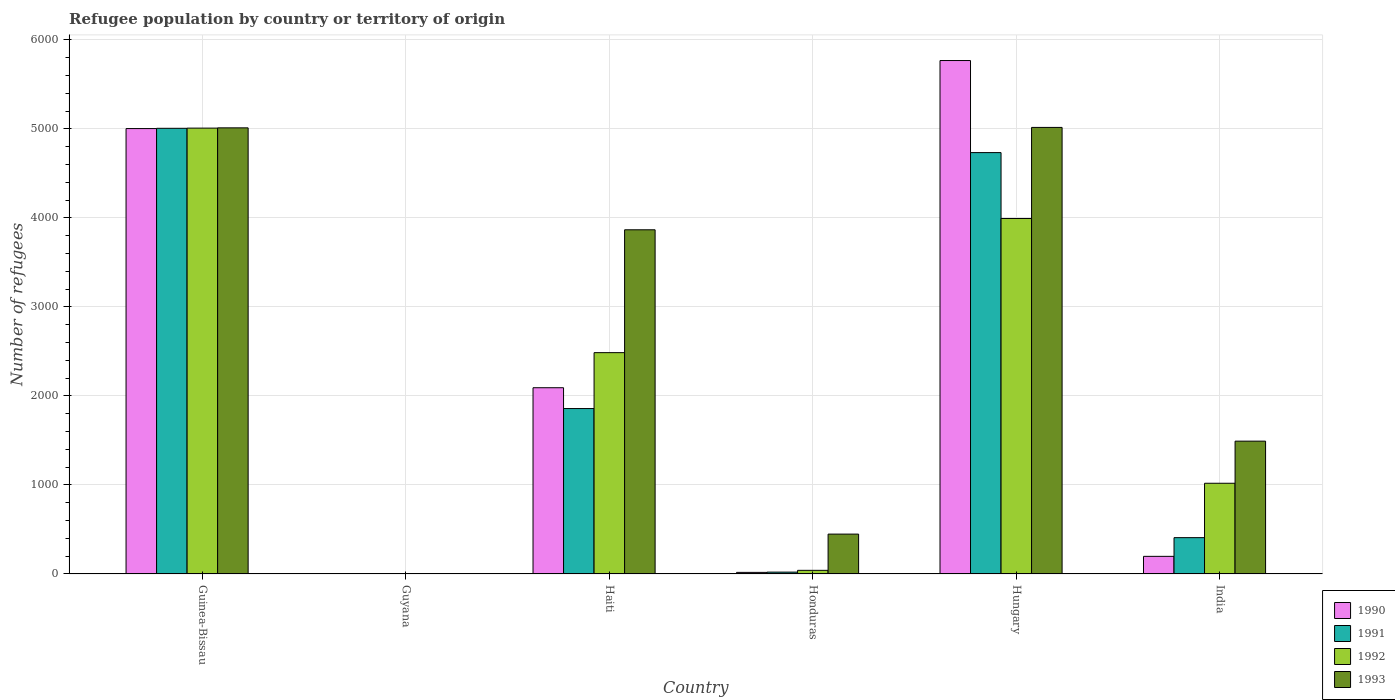How many different coloured bars are there?
Your answer should be very brief. 4. What is the label of the 4th group of bars from the left?
Give a very brief answer. Honduras. What is the number of refugees in 1991 in India?
Make the answer very short. 408. Across all countries, what is the maximum number of refugees in 1993?
Keep it short and to the point. 5016. In which country was the number of refugees in 1990 maximum?
Offer a terse response. Hungary. In which country was the number of refugees in 1993 minimum?
Offer a terse response. Guyana. What is the total number of refugees in 1990 in the graph?
Keep it short and to the point. 1.31e+04. What is the difference between the number of refugees in 1993 in Guyana and that in Hungary?
Keep it short and to the point. -5012. What is the difference between the number of refugees in 1990 in Honduras and the number of refugees in 1991 in Hungary?
Offer a very short reply. -4715. What is the average number of refugees in 1990 per country?
Offer a terse response. 2180. What is the difference between the number of refugees of/in 1990 and number of refugees of/in 1993 in Haiti?
Make the answer very short. -1774. What is the ratio of the number of refugees in 1993 in Guyana to that in India?
Offer a terse response. 0. What is the difference between the highest and the second highest number of refugees in 1991?
Provide a short and direct response. -2875. What is the difference between the highest and the lowest number of refugees in 1991?
Make the answer very short. 5005. In how many countries, is the number of refugees in 1991 greater than the average number of refugees in 1991 taken over all countries?
Keep it short and to the point. 2. Is the sum of the number of refugees in 1990 in Haiti and Hungary greater than the maximum number of refugees in 1992 across all countries?
Keep it short and to the point. Yes. What does the 3rd bar from the left in Honduras represents?
Keep it short and to the point. 1992. What does the 1st bar from the right in Honduras represents?
Offer a terse response. 1993. What is the difference between two consecutive major ticks on the Y-axis?
Your response must be concise. 1000. Are the values on the major ticks of Y-axis written in scientific E-notation?
Offer a terse response. No. Does the graph contain grids?
Ensure brevity in your answer.  Yes. How many legend labels are there?
Provide a succinct answer. 4. What is the title of the graph?
Offer a terse response. Refugee population by country or territory of origin. Does "1975" appear as one of the legend labels in the graph?
Your answer should be compact. No. What is the label or title of the X-axis?
Provide a succinct answer. Country. What is the label or title of the Y-axis?
Your answer should be compact. Number of refugees. What is the Number of refugees in 1990 in Guinea-Bissau?
Ensure brevity in your answer.  5003. What is the Number of refugees of 1991 in Guinea-Bissau?
Your answer should be very brief. 5006. What is the Number of refugees in 1992 in Guinea-Bissau?
Provide a short and direct response. 5008. What is the Number of refugees of 1993 in Guinea-Bissau?
Ensure brevity in your answer.  5011. What is the Number of refugees in 1991 in Guyana?
Your answer should be compact. 1. What is the Number of refugees in 1992 in Guyana?
Provide a succinct answer. 2. What is the Number of refugees in 1990 in Haiti?
Offer a very short reply. 2092. What is the Number of refugees in 1991 in Haiti?
Ensure brevity in your answer.  1858. What is the Number of refugees in 1992 in Haiti?
Keep it short and to the point. 2486. What is the Number of refugees of 1993 in Haiti?
Provide a short and direct response. 3866. What is the Number of refugees in 1993 in Honduras?
Give a very brief answer. 448. What is the Number of refugees in 1990 in Hungary?
Give a very brief answer. 5767. What is the Number of refugees in 1991 in Hungary?
Offer a very short reply. 4733. What is the Number of refugees in 1992 in Hungary?
Ensure brevity in your answer.  3993. What is the Number of refugees of 1993 in Hungary?
Your response must be concise. 5016. What is the Number of refugees in 1990 in India?
Give a very brief answer. 198. What is the Number of refugees in 1991 in India?
Provide a short and direct response. 408. What is the Number of refugees in 1992 in India?
Your answer should be compact. 1019. What is the Number of refugees in 1993 in India?
Offer a very short reply. 1492. Across all countries, what is the maximum Number of refugees in 1990?
Your answer should be very brief. 5767. Across all countries, what is the maximum Number of refugees of 1991?
Provide a short and direct response. 5006. Across all countries, what is the maximum Number of refugees of 1992?
Give a very brief answer. 5008. Across all countries, what is the maximum Number of refugees in 1993?
Keep it short and to the point. 5016. Across all countries, what is the minimum Number of refugees of 1991?
Your response must be concise. 1. What is the total Number of refugees of 1990 in the graph?
Your answer should be very brief. 1.31e+04. What is the total Number of refugees of 1991 in the graph?
Provide a short and direct response. 1.20e+04. What is the total Number of refugees of 1992 in the graph?
Offer a terse response. 1.25e+04. What is the total Number of refugees of 1993 in the graph?
Offer a terse response. 1.58e+04. What is the difference between the Number of refugees of 1990 in Guinea-Bissau and that in Guyana?
Provide a short and direct response. 5001. What is the difference between the Number of refugees of 1991 in Guinea-Bissau and that in Guyana?
Offer a very short reply. 5005. What is the difference between the Number of refugees in 1992 in Guinea-Bissau and that in Guyana?
Your answer should be compact. 5006. What is the difference between the Number of refugees in 1993 in Guinea-Bissau and that in Guyana?
Your answer should be very brief. 5007. What is the difference between the Number of refugees in 1990 in Guinea-Bissau and that in Haiti?
Make the answer very short. 2911. What is the difference between the Number of refugees in 1991 in Guinea-Bissau and that in Haiti?
Your response must be concise. 3148. What is the difference between the Number of refugees of 1992 in Guinea-Bissau and that in Haiti?
Provide a succinct answer. 2522. What is the difference between the Number of refugees of 1993 in Guinea-Bissau and that in Haiti?
Provide a succinct answer. 1145. What is the difference between the Number of refugees in 1990 in Guinea-Bissau and that in Honduras?
Your answer should be very brief. 4985. What is the difference between the Number of refugees in 1991 in Guinea-Bissau and that in Honduras?
Your answer should be compact. 4985. What is the difference between the Number of refugees of 1992 in Guinea-Bissau and that in Honduras?
Keep it short and to the point. 4967. What is the difference between the Number of refugees in 1993 in Guinea-Bissau and that in Honduras?
Offer a very short reply. 4563. What is the difference between the Number of refugees of 1990 in Guinea-Bissau and that in Hungary?
Your response must be concise. -764. What is the difference between the Number of refugees of 1991 in Guinea-Bissau and that in Hungary?
Offer a terse response. 273. What is the difference between the Number of refugees of 1992 in Guinea-Bissau and that in Hungary?
Ensure brevity in your answer.  1015. What is the difference between the Number of refugees in 1990 in Guinea-Bissau and that in India?
Give a very brief answer. 4805. What is the difference between the Number of refugees in 1991 in Guinea-Bissau and that in India?
Your answer should be very brief. 4598. What is the difference between the Number of refugees in 1992 in Guinea-Bissau and that in India?
Make the answer very short. 3989. What is the difference between the Number of refugees of 1993 in Guinea-Bissau and that in India?
Offer a very short reply. 3519. What is the difference between the Number of refugees in 1990 in Guyana and that in Haiti?
Provide a short and direct response. -2090. What is the difference between the Number of refugees of 1991 in Guyana and that in Haiti?
Ensure brevity in your answer.  -1857. What is the difference between the Number of refugees of 1992 in Guyana and that in Haiti?
Make the answer very short. -2484. What is the difference between the Number of refugees in 1993 in Guyana and that in Haiti?
Provide a short and direct response. -3862. What is the difference between the Number of refugees of 1990 in Guyana and that in Honduras?
Make the answer very short. -16. What is the difference between the Number of refugees of 1991 in Guyana and that in Honduras?
Give a very brief answer. -20. What is the difference between the Number of refugees of 1992 in Guyana and that in Honduras?
Your response must be concise. -39. What is the difference between the Number of refugees of 1993 in Guyana and that in Honduras?
Your answer should be compact. -444. What is the difference between the Number of refugees of 1990 in Guyana and that in Hungary?
Ensure brevity in your answer.  -5765. What is the difference between the Number of refugees in 1991 in Guyana and that in Hungary?
Offer a terse response. -4732. What is the difference between the Number of refugees of 1992 in Guyana and that in Hungary?
Your response must be concise. -3991. What is the difference between the Number of refugees in 1993 in Guyana and that in Hungary?
Your answer should be very brief. -5012. What is the difference between the Number of refugees of 1990 in Guyana and that in India?
Make the answer very short. -196. What is the difference between the Number of refugees of 1991 in Guyana and that in India?
Provide a succinct answer. -407. What is the difference between the Number of refugees of 1992 in Guyana and that in India?
Provide a short and direct response. -1017. What is the difference between the Number of refugees of 1993 in Guyana and that in India?
Your response must be concise. -1488. What is the difference between the Number of refugees in 1990 in Haiti and that in Honduras?
Your response must be concise. 2074. What is the difference between the Number of refugees of 1991 in Haiti and that in Honduras?
Give a very brief answer. 1837. What is the difference between the Number of refugees in 1992 in Haiti and that in Honduras?
Your response must be concise. 2445. What is the difference between the Number of refugees of 1993 in Haiti and that in Honduras?
Make the answer very short. 3418. What is the difference between the Number of refugees of 1990 in Haiti and that in Hungary?
Give a very brief answer. -3675. What is the difference between the Number of refugees in 1991 in Haiti and that in Hungary?
Offer a very short reply. -2875. What is the difference between the Number of refugees in 1992 in Haiti and that in Hungary?
Ensure brevity in your answer.  -1507. What is the difference between the Number of refugees in 1993 in Haiti and that in Hungary?
Offer a very short reply. -1150. What is the difference between the Number of refugees of 1990 in Haiti and that in India?
Your answer should be very brief. 1894. What is the difference between the Number of refugees of 1991 in Haiti and that in India?
Give a very brief answer. 1450. What is the difference between the Number of refugees in 1992 in Haiti and that in India?
Your answer should be compact. 1467. What is the difference between the Number of refugees in 1993 in Haiti and that in India?
Your answer should be very brief. 2374. What is the difference between the Number of refugees of 1990 in Honduras and that in Hungary?
Offer a terse response. -5749. What is the difference between the Number of refugees of 1991 in Honduras and that in Hungary?
Offer a terse response. -4712. What is the difference between the Number of refugees of 1992 in Honduras and that in Hungary?
Give a very brief answer. -3952. What is the difference between the Number of refugees in 1993 in Honduras and that in Hungary?
Provide a succinct answer. -4568. What is the difference between the Number of refugees in 1990 in Honduras and that in India?
Provide a short and direct response. -180. What is the difference between the Number of refugees of 1991 in Honduras and that in India?
Ensure brevity in your answer.  -387. What is the difference between the Number of refugees in 1992 in Honduras and that in India?
Your answer should be compact. -978. What is the difference between the Number of refugees in 1993 in Honduras and that in India?
Your response must be concise. -1044. What is the difference between the Number of refugees of 1990 in Hungary and that in India?
Ensure brevity in your answer.  5569. What is the difference between the Number of refugees of 1991 in Hungary and that in India?
Give a very brief answer. 4325. What is the difference between the Number of refugees of 1992 in Hungary and that in India?
Give a very brief answer. 2974. What is the difference between the Number of refugees of 1993 in Hungary and that in India?
Ensure brevity in your answer.  3524. What is the difference between the Number of refugees of 1990 in Guinea-Bissau and the Number of refugees of 1991 in Guyana?
Offer a very short reply. 5002. What is the difference between the Number of refugees in 1990 in Guinea-Bissau and the Number of refugees in 1992 in Guyana?
Give a very brief answer. 5001. What is the difference between the Number of refugees in 1990 in Guinea-Bissau and the Number of refugees in 1993 in Guyana?
Your response must be concise. 4999. What is the difference between the Number of refugees of 1991 in Guinea-Bissau and the Number of refugees of 1992 in Guyana?
Provide a short and direct response. 5004. What is the difference between the Number of refugees of 1991 in Guinea-Bissau and the Number of refugees of 1993 in Guyana?
Offer a very short reply. 5002. What is the difference between the Number of refugees of 1992 in Guinea-Bissau and the Number of refugees of 1993 in Guyana?
Your answer should be very brief. 5004. What is the difference between the Number of refugees in 1990 in Guinea-Bissau and the Number of refugees in 1991 in Haiti?
Offer a very short reply. 3145. What is the difference between the Number of refugees of 1990 in Guinea-Bissau and the Number of refugees of 1992 in Haiti?
Keep it short and to the point. 2517. What is the difference between the Number of refugees in 1990 in Guinea-Bissau and the Number of refugees in 1993 in Haiti?
Offer a very short reply. 1137. What is the difference between the Number of refugees of 1991 in Guinea-Bissau and the Number of refugees of 1992 in Haiti?
Your answer should be very brief. 2520. What is the difference between the Number of refugees in 1991 in Guinea-Bissau and the Number of refugees in 1993 in Haiti?
Keep it short and to the point. 1140. What is the difference between the Number of refugees of 1992 in Guinea-Bissau and the Number of refugees of 1993 in Haiti?
Give a very brief answer. 1142. What is the difference between the Number of refugees in 1990 in Guinea-Bissau and the Number of refugees in 1991 in Honduras?
Keep it short and to the point. 4982. What is the difference between the Number of refugees of 1990 in Guinea-Bissau and the Number of refugees of 1992 in Honduras?
Your response must be concise. 4962. What is the difference between the Number of refugees of 1990 in Guinea-Bissau and the Number of refugees of 1993 in Honduras?
Your response must be concise. 4555. What is the difference between the Number of refugees in 1991 in Guinea-Bissau and the Number of refugees in 1992 in Honduras?
Your response must be concise. 4965. What is the difference between the Number of refugees of 1991 in Guinea-Bissau and the Number of refugees of 1993 in Honduras?
Give a very brief answer. 4558. What is the difference between the Number of refugees in 1992 in Guinea-Bissau and the Number of refugees in 1993 in Honduras?
Your answer should be very brief. 4560. What is the difference between the Number of refugees in 1990 in Guinea-Bissau and the Number of refugees in 1991 in Hungary?
Your answer should be compact. 270. What is the difference between the Number of refugees of 1990 in Guinea-Bissau and the Number of refugees of 1992 in Hungary?
Give a very brief answer. 1010. What is the difference between the Number of refugees in 1990 in Guinea-Bissau and the Number of refugees in 1993 in Hungary?
Your answer should be very brief. -13. What is the difference between the Number of refugees in 1991 in Guinea-Bissau and the Number of refugees in 1992 in Hungary?
Give a very brief answer. 1013. What is the difference between the Number of refugees of 1990 in Guinea-Bissau and the Number of refugees of 1991 in India?
Ensure brevity in your answer.  4595. What is the difference between the Number of refugees of 1990 in Guinea-Bissau and the Number of refugees of 1992 in India?
Your answer should be compact. 3984. What is the difference between the Number of refugees of 1990 in Guinea-Bissau and the Number of refugees of 1993 in India?
Make the answer very short. 3511. What is the difference between the Number of refugees in 1991 in Guinea-Bissau and the Number of refugees in 1992 in India?
Make the answer very short. 3987. What is the difference between the Number of refugees of 1991 in Guinea-Bissau and the Number of refugees of 1993 in India?
Your answer should be very brief. 3514. What is the difference between the Number of refugees in 1992 in Guinea-Bissau and the Number of refugees in 1993 in India?
Provide a short and direct response. 3516. What is the difference between the Number of refugees in 1990 in Guyana and the Number of refugees in 1991 in Haiti?
Offer a terse response. -1856. What is the difference between the Number of refugees of 1990 in Guyana and the Number of refugees of 1992 in Haiti?
Ensure brevity in your answer.  -2484. What is the difference between the Number of refugees of 1990 in Guyana and the Number of refugees of 1993 in Haiti?
Provide a short and direct response. -3864. What is the difference between the Number of refugees in 1991 in Guyana and the Number of refugees in 1992 in Haiti?
Keep it short and to the point. -2485. What is the difference between the Number of refugees of 1991 in Guyana and the Number of refugees of 1993 in Haiti?
Offer a terse response. -3865. What is the difference between the Number of refugees of 1992 in Guyana and the Number of refugees of 1993 in Haiti?
Your answer should be compact. -3864. What is the difference between the Number of refugees in 1990 in Guyana and the Number of refugees in 1992 in Honduras?
Offer a terse response. -39. What is the difference between the Number of refugees in 1990 in Guyana and the Number of refugees in 1993 in Honduras?
Give a very brief answer. -446. What is the difference between the Number of refugees of 1991 in Guyana and the Number of refugees of 1992 in Honduras?
Offer a terse response. -40. What is the difference between the Number of refugees in 1991 in Guyana and the Number of refugees in 1993 in Honduras?
Provide a short and direct response. -447. What is the difference between the Number of refugees in 1992 in Guyana and the Number of refugees in 1993 in Honduras?
Your response must be concise. -446. What is the difference between the Number of refugees in 1990 in Guyana and the Number of refugees in 1991 in Hungary?
Ensure brevity in your answer.  -4731. What is the difference between the Number of refugees of 1990 in Guyana and the Number of refugees of 1992 in Hungary?
Provide a succinct answer. -3991. What is the difference between the Number of refugees in 1990 in Guyana and the Number of refugees in 1993 in Hungary?
Keep it short and to the point. -5014. What is the difference between the Number of refugees in 1991 in Guyana and the Number of refugees in 1992 in Hungary?
Provide a succinct answer. -3992. What is the difference between the Number of refugees of 1991 in Guyana and the Number of refugees of 1993 in Hungary?
Offer a very short reply. -5015. What is the difference between the Number of refugees in 1992 in Guyana and the Number of refugees in 1993 in Hungary?
Your response must be concise. -5014. What is the difference between the Number of refugees in 1990 in Guyana and the Number of refugees in 1991 in India?
Your response must be concise. -406. What is the difference between the Number of refugees of 1990 in Guyana and the Number of refugees of 1992 in India?
Your answer should be very brief. -1017. What is the difference between the Number of refugees in 1990 in Guyana and the Number of refugees in 1993 in India?
Your response must be concise. -1490. What is the difference between the Number of refugees of 1991 in Guyana and the Number of refugees of 1992 in India?
Make the answer very short. -1018. What is the difference between the Number of refugees of 1991 in Guyana and the Number of refugees of 1993 in India?
Make the answer very short. -1491. What is the difference between the Number of refugees of 1992 in Guyana and the Number of refugees of 1993 in India?
Offer a very short reply. -1490. What is the difference between the Number of refugees in 1990 in Haiti and the Number of refugees in 1991 in Honduras?
Offer a terse response. 2071. What is the difference between the Number of refugees in 1990 in Haiti and the Number of refugees in 1992 in Honduras?
Give a very brief answer. 2051. What is the difference between the Number of refugees of 1990 in Haiti and the Number of refugees of 1993 in Honduras?
Provide a succinct answer. 1644. What is the difference between the Number of refugees in 1991 in Haiti and the Number of refugees in 1992 in Honduras?
Offer a terse response. 1817. What is the difference between the Number of refugees of 1991 in Haiti and the Number of refugees of 1993 in Honduras?
Your response must be concise. 1410. What is the difference between the Number of refugees in 1992 in Haiti and the Number of refugees in 1993 in Honduras?
Provide a short and direct response. 2038. What is the difference between the Number of refugees in 1990 in Haiti and the Number of refugees in 1991 in Hungary?
Your response must be concise. -2641. What is the difference between the Number of refugees of 1990 in Haiti and the Number of refugees of 1992 in Hungary?
Provide a short and direct response. -1901. What is the difference between the Number of refugees in 1990 in Haiti and the Number of refugees in 1993 in Hungary?
Offer a terse response. -2924. What is the difference between the Number of refugees of 1991 in Haiti and the Number of refugees of 1992 in Hungary?
Your answer should be compact. -2135. What is the difference between the Number of refugees of 1991 in Haiti and the Number of refugees of 1993 in Hungary?
Provide a short and direct response. -3158. What is the difference between the Number of refugees in 1992 in Haiti and the Number of refugees in 1993 in Hungary?
Provide a succinct answer. -2530. What is the difference between the Number of refugees of 1990 in Haiti and the Number of refugees of 1991 in India?
Provide a succinct answer. 1684. What is the difference between the Number of refugees of 1990 in Haiti and the Number of refugees of 1992 in India?
Provide a succinct answer. 1073. What is the difference between the Number of refugees of 1990 in Haiti and the Number of refugees of 1993 in India?
Your answer should be very brief. 600. What is the difference between the Number of refugees of 1991 in Haiti and the Number of refugees of 1992 in India?
Ensure brevity in your answer.  839. What is the difference between the Number of refugees of 1991 in Haiti and the Number of refugees of 1993 in India?
Your answer should be very brief. 366. What is the difference between the Number of refugees in 1992 in Haiti and the Number of refugees in 1993 in India?
Provide a succinct answer. 994. What is the difference between the Number of refugees of 1990 in Honduras and the Number of refugees of 1991 in Hungary?
Your answer should be very brief. -4715. What is the difference between the Number of refugees in 1990 in Honduras and the Number of refugees in 1992 in Hungary?
Provide a succinct answer. -3975. What is the difference between the Number of refugees of 1990 in Honduras and the Number of refugees of 1993 in Hungary?
Your response must be concise. -4998. What is the difference between the Number of refugees of 1991 in Honduras and the Number of refugees of 1992 in Hungary?
Your answer should be compact. -3972. What is the difference between the Number of refugees of 1991 in Honduras and the Number of refugees of 1993 in Hungary?
Make the answer very short. -4995. What is the difference between the Number of refugees in 1992 in Honduras and the Number of refugees in 1993 in Hungary?
Your response must be concise. -4975. What is the difference between the Number of refugees in 1990 in Honduras and the Number of refugees in 1991 in India?
Offer a terse response. -390. What is the difference between the Number of refugees of 1990 in Honduras and the Number of refugees of 1992 in India?
Provide a short and direct response. -1001. What is the difference between the Number of refugees of 1990 in Honduras and the Number of refugees of 1993 in India?
Your answer should be compact. -1474. What is the difference between the Number of refugees of 1991 in Honduras and the Number of refugees of 1992 in India?
Keep it short and to the point. -998. What is the difference between the Number of refugees of 1991 in Honduras and the Number of refugees of 1993 in India?
Provide a succinct answer. -1471. What is the difference between the Number of refugees in 1992 in Honduras and the Number of refugees in 1993 in India?
Give a very brief answer. -1451. What is the difference between the Number of refugees of 1990 in Hungary and the Number of refugees of 1991 in India?
Give a very brief answer. 5359. What is the difference between the Number of refugees in 1990 in Hungary and the Number of refugees in 1992 in India?
Ensure brevity in your answer.  4748. What is the difference between the Number of refugees in 1990 in Hungary and the Number of refugees in 1993 in India?
Offer a very short reply. 4275. What is the difference between the Number of refugees in 1991 in Hungary and the Number of refugees in 1992 in India?
Give a very brief answer. 3714. What is the difference between the Number of refugees in 1991 in Hungary and the Number of refugees in 1993 in India?
Ensure brevity in your answer.  3241. What is the difference between the Number of refugees in 1992 in Hungary and the Number of refugees in 1993 in India?
Offer a terse response. 2501. What is the average Number of refugees of 1990 per country?
Your answer should be compact. 2180. What is the average Number of refugees in 1991 per country?
Offer a very short reply. 2004.5. What is the average Number of refugees in 1992 per country?
Offer a terse response. 2091.5. What is the average Number of refugees of 1993 per country?
Provide a succinct answer. 2639.5. What is the difference between the Number of refugees in 1990 and Number of refugees in 1991 in Guinea-Bissau?
Offer a very short reply. -3. What is the difference between the Number of refugees of 1992 and Number of refugees of 1993 in Guinea-Bissau?
Provide a succinct answer. -3. What is the difference between the Number of refugees of 1990 and Number of refugees of 1991 in Guyana?
Provide a short and direct response. 1. What is the difference between the Number of refugees of 1991 and Number of refugees of 1992 in Guyana?
Ensure brevity in your answer.  -1. What is the difference between the Number of refugees of 1991 and Number of refugees of 1993 in Guyana?
Your response must be concise. -3. What is the difference between the Number of refugees of 1992 and Number of refugees of 1993 in Guyana?
Provide a short and direct response. -2. What is the difference between the Number of refugees of 1990 and Number of refugees of 1991 in Haiti?
Provide a succinct answer. 234. What is the difference between the Number of refugees of 1990 and Number of refugees of 1992 in Haiti?
Your answer should be compact. -394. What is the difference between the Number of refugees of 1990 and Number of refugees of 1993 in Haiti?
Provide a succinct answer. -1774. What is the difference between the Number of refugees of 1991 and Number of refugees of 1992 in Haiti?
Keep it short and to the point. -628. What is the difference between the Number of refugees of 1991 and Number of refugees of 1993 in Haiti?
Your answer should be compact. -2008. What is the difference between the Number of refugees in 1992 and Number of refugees in 1993 in Haiti?
Offer a terse response. -1380. What is the difference between the Number of refugees of 1990 and Number of refugees of 1992 in Honduras?
Ensure brevity in your answer.  -23. What is the difference between the Number of refugees in 1990 and Number of refugees in 1993 in Honduras?
Ensure brevity in your answer.  -430. What is the difference between the Number of refugees in 1991 and Number of refugees in 1992 in Honduras?
Keep it short and to the point. -20. What is the difference between the Number of refugees in 1991 and Number of refugees in 1993 in Honduras?
Ensure brevity in your answer.  -427. What is the difference between the Number of refugees of 1992 and Number of refugees of 1993 in Honduras?
Ensure brevity in your answer.  -407. What is the difference between the Number of refugees of 1990 and Number of refugees of 1991 in Hungary?
Make the answer very short. 1034. What is the difference between the Number of refugees of 1990 and Number of refugees of 1992 in Hungary?
Your answer should be very brief. 1774. What is the difference between the Number of refugees of 1990 and Number of refugees of 1993 in Hungary?
Your answer should be very brief. 751. What is the difference between the Number of refugees in 1991 and Number of refugees in 1992 in Hungary?
Offer a terse response. 740. What is the difference between the Number of refugees of 1991 and Number of refugees of 1993 in Hungary?
Your answer should be very brief. -283. What is the difference between the Number of refugees in 1992 and Number of refugees in 1993 in Hungary?
Offer a terse response. -1023. What is the difference between the Number of refugees of 1990 and Number of refugees of 1991 in India?
Provide a succinct answer. -210. What is the difference between the Number of refugees in 1990 and Number of refugees in 1992 in India?
Offer a very short reply. -821. What is the difference between the Number of refugees of 1990 and Number of refugees of 1993 in India?
Keep it short and to the point. -1294. What is the difference between the Number of refugees in 1991 and Number of refugees in 1992 in India?
Keep it short and to the point. -611. What is the difference between the Number of refugees in 1991 and Number of refugees in 1993 in India?
Provide a succinct answer. -1084. What is the difference between the Number of refugees in 1992 and Number of refugees in 1993 in India?
Provide a succinct answer. -473. What is the ratio of the Number of refugees of 1990 in Guinea-Bissau to that in Guyana?
Provide a succinct answer. 2501.5. What is the ratio of the Number of refugees of 1991 in Guinea-Bissau to that in Guyana?
Provide a short and direct response. 5006. What is the ratio of the Number of refugees in 1992 in Guinea-Bissau to that in Guyana?
Offer a very short reply. 2504. What is the ratio of the Number of refugees of 1993 in Guinea-Bissau to that in Guyana?
Offer a terse response. 1252.75. What is the ratio of the Number of refugees of 1990 in Guinea-Bissau to that in Haiti?
Your answer should be very brief. 2.39. What is the ratio of the Number of refugees of 1991 in Guinea-Bissau to that in Haiti?
Make the answer very short. 2.69. What is the ratio of the Number of refugees in 1992 in Guinea-Bissau to that in Haiti?
Provide a short and direct response. 2.01. What is the ratio of the Number of refugees of 1993 in Guinea-Bissau to that in Haiti?
Keep it short and to the point. 1.3. What is the ratio of the Number of refugees of 1990 in Guinea-Bissau to that in Honduras?
Your answer should be compact. 277.94. What is the ratio of the Number of refugees in 1991 in Guinea-Bissau to that in Honduras?
Your response must be concise. 238.38. What is the ratio of the Number of refugees in 1992 in Guinea-Bissau to that in Honduras?
Your response must be concise. 122.15. What is the ratio of the Number of refugees of 1993 in Guinea-Bissau to that in Honduras?
Offer a terse response. 11.19. What is the ratio of the Number of refugees of 1990 in Guinea-Bissau to that in Hungary?
Your response must be concise. 0.87. What is the ratio of the Number of refugees in 1991 in Guinea-Bissau to that in Hungary?
Offer a terse response. 1.06. What is the ratio of the Number of refugees in 1992 in Guinea-Bissau to that in Hungary?
Make the answer very short. 1.25. What is the ratio of the Number of refugees in 1993 in Guinea-Bissau to that in Hungary?
Offer a very short reply. 1. What is the ratio of the Number of refugees in 1990 in Guinea-Bissau to that in India?
Offer a very short reply. 25.27. What is the ratio of the Number of refugees of 1991 in Guinea-Bissau to that in India?
Keep it short and to the point. 12.27. What is the ratio of the Number of refugees in 1992 in Guinea-Bissau to that in India?
Provide a short and direct response. 4.91. What is the ratio of the Number of refugees of 1993 in Guinea-Bissau to that in India?
Keep it short and to the point. 3.36. What is the ratio of the Number of refugees of 1990 in Guyana to that in Haiti?
Give a very brief answer. 0. What is the ratio of the Number of refugees in 1991 in Guyana to that in Haiti?
Offer a very short reply. 0. What is the ratio of the Number of refugees in 1992 in Guyana to that in Haiti?
Give a very brief answer. 0. What is the ratio of the Number of refugees of 1993 in Guyana to that in Haiti?
Offer a very short reply. 0. What is the ratio of the Number of refugees in 1990 in Guyana to that in Honduras?
Offer a very short reply. 0.11. What is the ratio of the Number of refugees in 1991 in Guyana to that in Honduras?
Keep it short and to the point. 0.05. What is the ratio of the Number of refugees in 1992 in Guyana to that in Honduras?
Ensure brevity in your answer.  0.05. What is the ratio of the Number of refugees in 1993 in Guyana to that in Honduras?
Give a very brief answer. 0.01. What is the ratio of the Number of refugees in 1992 in Guyana to that in Hungary?
Give a very brief answer. 0. What is the ratio of the Number of refugees in 1993 in Guyana to that in Hungary?
Make the answer very short. 0. What is the ratio of the Number of refugees in 1990 in Guyana to that in India?
Your answer should be very brief. 0.01. What is the ratio of the Number of refugees of 1991 in Guyana to that in India?
Give a very brief answer. 0. What is the ratio of the Number of refugees in 1992 in Guyana to that in India?
Your answer should be very brief. 0. What is the ratio of the Number of refugees of 1993 in Guyana to that in India?
Keep it short and to the point. 0. What is the ratio of the Number of refugees in 1990 in Haiti to that in Honduras?
Your answer should be compact. 116.22. What is the ratio of the Number of refugees of 1991 in Haiti to that in Honduras?
Offer a terse response. 88.48. What is the ratio of the Number of refugees in 1992 in Haiti to that in Honduras?
Provide a succinct answer. 60.63. What is the ratio of the Number of refugees of 1993 in Haiti to that in Honduras?
Offer a very short reply. 8.63. What is the ratio of the Number of refugees in 1990 in Haiti to that in Hungary?
Make the answer very short. 0.36. What is the ratio of the Number of refugees in 1991 in Haiti to that in Hungary?
Provide a succinct answer. 0.39. What is the ratio of the Number of refugees of 1992 in Haiti to that in Hungary?
Give a very brief answer. 0.62. What is the ratio of the Number of refugees of 1993 in Haiti to that in Hungary?
Make the answer very short. 0.77. What is the ratio of the Number of refugees in 1990 in Haiti to that in India?
Provide a succinct answer. 10.57. What is the ratio of the Number of refugees in 1991 in Haiti to that in India?
Your answer should be very brief. 4.55. What is the ratio of the Number of refugees of 1992 in Haiti to that in India?
Provide a succinct answer. 2.44. What is the ratio of the Number of refugees of 1993 in Haiti to that in India?
Provide a succinct answer. 2.59. What is the ratio of the Number of refugees of 1990 in Honduras to that in Hungary?
Offer a terse response. 0. What is the ratio of the Number of refugees of 1991 in Honduras to that in Hungary?
Your answer should be very brief. 0. What is the ratio of the Number of refugees in 1992 in Honduras to that in Hungary?
Ensure brevity in your answer.  0.01. What is the ratio of the Number of refugees of 1993 in Honduras to that in Hungary?
Provide a succinct answer. 0.09. What is the ratio of the Number of refugees of 1990 in Honduras to that in India?
Make the answer very short. 0.09. What is the ratio of the Number of refugees of 1991 in Honduras to that in India?
Provide a short and direct response. 0.05. What is the ratio of the Number of refugees of 1992 in Honduras to that in India?
Offer a terse response. 0.04. What is the ratio of the Number of refugees of 1993 in Honduras to that in India?
Your answer should be very brief. 0.3. What is the ratio of the Number of refugees of 1990 in Hungary to that in India?
Your answer should be very brief. 29.13. What is the ratio of the Number of refugees of 1991 in Hungary to that in India?
Your answer should be very brief. 11.6. What is the ratio of the Number of refugees of 1992 in Hungary to that in India?
Keep it short and to the point. 3.92. What is the ratio of the Number of refugees of 1993 in Hungary to that in India?
Your answer should be compact. 3.36. What is the difference between the highest and the second highest Number of refugees in 1990?
Make the answer very short. 764. What is the difference between the highest and the second highest Number of refugees of 1991?
Your answer should be very brief. 273. What is the difference between the highest and the second highest Number of refugees of 1992?
Offer a terse response. 1015. What is the difference between the highest and the second highest Number of refugees in 1993?
Provide a short and direct response. 5. What is the difference between the highest and the lowest Number of refugees of 1990?
Ensure brevity in your answer.  5765. What is the difference between the highest and the lowest Number of refugees in 1991?
Keep it short and to the point. 5005. What is the difference between the highest and the lowest Number of refugees of 1992?
Keep it short and to the point. 5006. What is the difference between the highest and the lowest Number of refugees of 1993?
Offer a very short reply. 5012. 